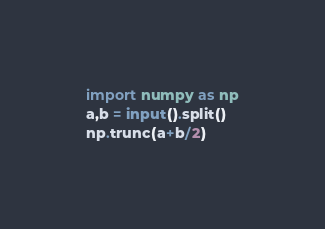<code> <loc_0><loc_0><loc_500><loc_500><_Python_>import numpy as np
a,b = input().split()
np.trunc(a+b/2)</code> 